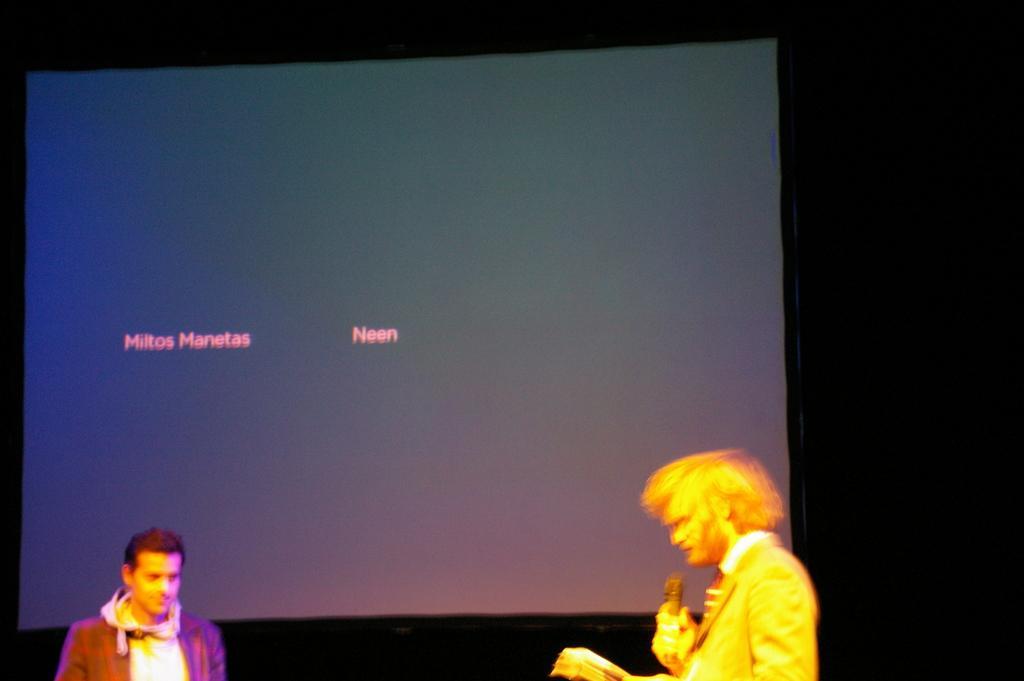In one or two sentences, can you explain what this image depicts? In this picture, we can see there are two people standing on the path and behind the people there is a screen. 